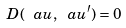<formula> <loc_0><loc_0><loc_500><loc_500>D ( \ a u , \ a u ^ { \prime } ) = 0</formula> 